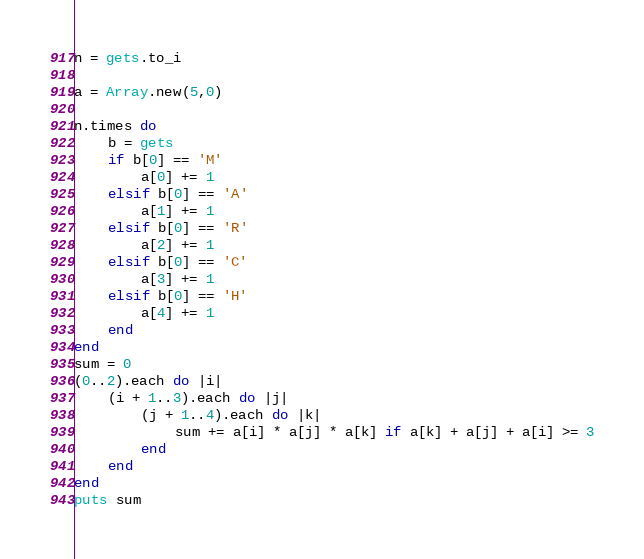Convert code to text. <code><loc_0><loc_0><loc_500><loc_500><_Ruby_>n = gets.to_i

a = Array.new(5,0)

n.times do 
    b = gets
    if b[0] == 'M'
        a[0] += 1
    elsif b[0] == 'A'
        a[1] += 1
    elsif b[0] == 'R'
        a[2] += 1
    elsif b[0] == 'C'
        a[3] += 1
    elsif b[0] == 'H'
        a[4] += 1
    end
end
sum = 0
(0..2).each do |i|
    (i + 1..3).each do |j|
        (j + 1..4).each do |k|
            sum += a[i] * a[j] * a[k] if a[k] + a[j] + a[i] >= 3
        end
    end
end
puts sum</code> 